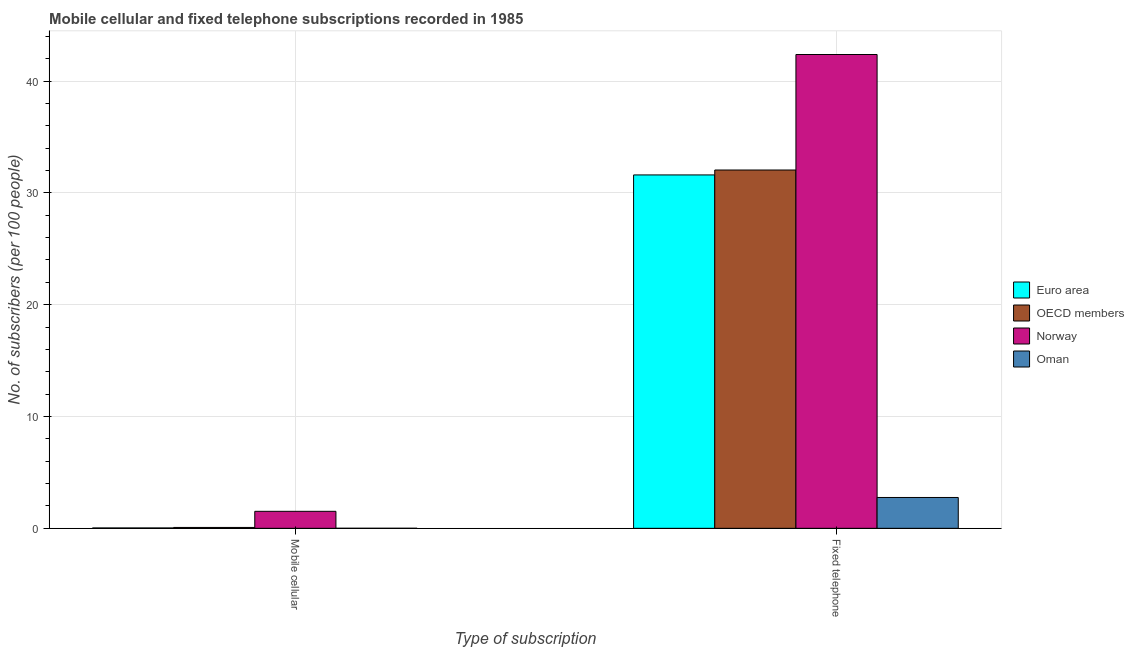How many different coloured bars are there?
Offer a very short reply. 4. How many groups of bars are there?
Your response must be concise. 2. How many bars are there on the 1st tick from the right?
Your answer should be compact. 4. What is the label of the 1st group of bars from the left?
Ensure brevity in your answer.  Mobile cellular. What is the number of fixed telephone subscribers in Oman?
Offer a very short reply. 2.76. Across all countries, what is the maximum number of mobile cellular subscribers?
Offer a terse response. 1.52. Across all countries, what is the minimum number of fixed telephone subscribers?
Offer a terse response. 2.76. In which country was the number of mobile cellular subscribers minimum?
Provide a succinct answer. Oman. What is the total number of mobile cellular subscribers in the graph?
Offer a terse response. 1.64. What is the difference between the number of mobile cellular subscribers in Euro area and that in OECD members?
Offer a terse response. -0.04. What is the difference between the number of mobile cellular subscribers in Norway and the number of fixed telephone subscribers in Oman?
Offer a very short reply. -1.24. What is the average number of mobile cellular subscribers per country?
Your answer should be very brief. 0.41. What is the difference between the number of fixed telephone subscribers and number of mobile cellular subscribers in OECD members?
Offer a terse response. 31.96. In how many countries, is the number of fixed telephone subscribers greater than 2 ?
Your answer should be very brief. 4. What is the ratio of the number of mobile cellular subscribers in Euro area to that in Norway?
Offer a terse response. 0.02. Is the number of fixed telephone subscribers in Euro area less than that in Oman?
Your response must be concise. No. In how many countries, is the number of mobile cellular subscribers greater than the average number of mobile cellular subscribers taken over all countries?
Offer a very short reply. 1. What does the 4th bar from the left in Mobile cellular represents?
Make the answer very short. Oman. What does the 3rd bar from the right in Fixed telephone represents?
Keep it short and to the point. OECD members. How many bars are there?
Make the answer very short. 8. Are all the bars in the graph horizontal?
Give a very brief answer. No. How many countries are there in the graph?
Your answer should be compact. 4. Are the values on the major ticks of Y-axis written in scientific E-notation?
Your response must be concise. No. Does the graph contain any zero values?
Provide a short and direct response. No. Does the graph contain grids?
Give a very brief answer. Yes. What is the title of the graph?
Your answer should be compact. Mobile cellular and fixed telephone subscriptions recorded in 1985. What is the label or title of the X-axis?
Keep it short and to the point. Type of subscription. What is the label or title of the Y-axis?
Your response must be concise. No. of subscribers (per 100 people). What is the No. of subscribers (per 100 people) of Euro area in Mobile cellular?
Offer a very short reply. 0.03. What is the No. of subscribers (per 100 people) of OECD members in Mobile cellular?
Your answer should be compact. 0.08. What is the No. of subscribers (per 100 people) in Norway in Mobile cellular?
Give a very brief answer. 1.52. What is the No. of subscribers (per 100 people) in Oman in Mobile cellular?
Make the answer very short. 0. What is the No. of subscribers (per 100 people) in Euro area in Fixed telephone?
Provide a succinct answer. 31.6. What is the No. of subscribers (per 100 people) of OECD members in Fixed telephone?
Make the answer very short. 32.04. What is the No. of subscribers (per 100 people) of Norway in Fixed telephone?
Offer a very short reply. 42.37. What is the No. of subscribers (per 100 people) in Oman in Fixed telephone?
Offer a very short reply. 2.76. Across all Type of subscription, what is the maximum No. of subscribers (per 100 people) in Euro area?
Your response must be concise. 31.6. Across all Type of subscription, what is the maximum No. of subscribers (per 100 people) of OECD members?
Provide a short and direct response. 32.04. Across all Type of subscription, what is the maximum No. of subscribers (per 100 people) of Norway?
Your response must be concise. 42.37. Across all Type of subscription, what is the maximum No. of subscribers (per 100 people) of Oman?
Keep it short and to the point. 2.76. Across all Type of subscription, what is the minimum No. of subscribers (per 100 people) in Euro area?
Keep it short and to the point. 0.03. Across all Type of subscription, what is the minimum No. of subscribers (per 100 people) of OECD members?
Give a very brief answer. 0.08. Across all Type of subscription, what is the minimum No. of subscribers (per 100 people) in Norway?
Your answer should be compact. 1.52. Across all Type of subscription, what is the minimum No. of subscribers (per 100 people) of Oman?
Your answer should be compact. 0. What is the total No. of subscribers (per 100 people) of Euro area in the graph?
Your answer should be very brief. 31.64. What is the total No. of subscribers (per 100 people) in OECD members in the graph?
Keep it short and to the point. 32.12. What is the total No. of subscribers (per 100 people) in Norway in the graph?
Your answer should be compact. 43.89. What is the total No. of subscribers (per 100 people) in Oman in the graph?
Your response must be concise. 2.76. What is the difference between the No. of subscribers (per 100 people) in Euro area in Mobile cellular and that in Fixed telephone?
Keep it short and to the point. -31.57. What is the difference between the No. of subscribers (per 100 people) of OECD members in Mobile cellular and that in Fixed telephone?
Offer a terse response. -31.96. What is the difference between the No. of subscribers (per 100 people) of Norway in Mobile cellular and that in Fixed telephone?
Make the answer very short. -40.85. What is the difference between the No. of subscribers (per 100 people) of Oman in Mobile cellular and that in Fixed telephone?
Your response must be concise. -2.75. What is the difference between the No. of subscribers (per 100 people) in Euro area in Mobile cellular and the No. of subscribers (per 100 people) in OECD members in Fixed telephone?
Your response must be concise. -32.01. What is the difference between the No. of subscribers (per 100 people) in Euro area in Mobile cellular and the No. of subscribers (per 100 people) in Norway in Fixed telephone?
Offer a terse response. -42.34. What is the difference between the No. of subscribers (per 100 people) of Euro area in Mobile cellular and the No. of subscribers (per 100 people) of Oman in Fixed telephone?
Give a very brief answer. -2.72. What is the difference between the No. of subscribers (per 100 people) in OECD members in Mobile cellular and the No. of subscribers (per 100 people) in Norway in Fixed telephone?
Provide a succinct answer. -42.29. What is the difference between the No. of subscribers (per 100 people) of OECD members in Mobile cellular and the No. of subscribers (per 100 people) of Oman in Fixed telephone?
Offer a terse response. -2.68. What is the difference between the No. of subscribers (per 100 people) in Norway in Mobile cellular and the No. of subscribers (per 100 people) in Oman in Fixed telephone?
Your answer should be compact. -1.24. What is the average No. of subscribers (per 100 people) in Euro area per Type of subscription?
Ensure brevity in your answer.  15.82. What is the average No. of subscribers (per 100 people) of OECD members per Type of subscription?
Provide a succinct answer. 16.06. What is the average No. of subscribers (per 100 people) in Norway per Type of subscription?
Provide a short and direct response. 21.95. What is the average No. of subscribers (per 100 people) in Oman per Type of subscription?
Make the answer very short. 1.38. What is the difference between the No. of subscribers (per 100 people) of Euro area and No. of subscribers (per 100 people) of OECD members in Mobile cellular?
Provide a succinct answer. -0.04. What is the difference between the No. of subscribers (per 100 people) of Euro area and No. of subscribers (per 100 people) of Norway in Mobile cellular?
Your answer should be very brief. -1.49. What is the difference between the No. of subscribers (per 100 people) of Euro area and No. of subscribers (per 100 people) of Oman in Mobile cellular?
Offer a very short reply. 0.03. What is the difference between the No. of subscribers (per 100 people) in OECD members and No. of subscribers (per 100 people) in Norway in Mobile cellular?
Ensure brevity in your answer.  -1.44. What is the difference between the No. of subscribers (per 100 people) in OECD members and No. of subscribers (per 100 people) in Oman in Mobile cellular?
Offer a very short reply. 0.07. What is the difference between the No. of subscribers (per 100 people) in Norway and No. of subscribers (per 100 people) in Oman in Mobile cellular?
Your answer should be very brief. 1.52. What is the difference between the No. of subscribers (per 100 people) of Euro area and No. of subscribers (per 100 people) of OECD members in Fixed telephone?
Give a very brief answer. -0.44. What is the difference between the No. of subscribers (per 100 people) in Euro area and No. of subscribers (per 100 people) in Norway in Fixed telephone?
Provide a short and direct response. -10.77. What is the difference between the No. of subscribers (per 100 people) of Euro area and No. of subscribers (per 100 people) of Oman in Fixed telephone?
Offer a very short reply. 28.84. What is the difference between the No. of subscribers (per 100 people) in OECD members and No. of subscribers (per 100 people) in Norway in Fixed telephone?
Your answer should be very brief. -10.33. What is the difference between the No. of subscribers (per 100 people) of OECD members and No. of subscribers (per 100 people) of Oman in Fixed telephone?
Your answer should be compact. 29.28. What is the difference between the No. of subscribers (per 100 people) of Norway and No. of subscribers (per 100 people) of Oman in Fixed telephone?
Keep it short and to the point. 39.61. What is the ratio of the No. of subscribers (per 100 people) in Euro area in Mobile cellular to that in Fixed telephone?
Offer a very short reply. 0. What is the ratio of the No. of subscribers (per 100 people) of OECD members in Mobile cellular to that in Fixed telephone?
Give a very brief answer. 0. What is the ratio of the No. of subscribers (per 100 people) of Norway in Mobile cellular to that in Fixed telephone?
Ensure brevity in your answer.  0.04. What is the ratio of the No. of subscribers (per 100 people) in Oman in Mobile cellular to that in Fixed telephone?
Your response must be concise. 0. What is the difference between the highest and the second highest No. of subscribers (per 100 people) in Euro area?
Your answer should be compact. 31.57. What is the difference between the highest and the second highest No. of subscribers (per 100 people) in OECD members?
Offer a very short reply. 31.96. What is the difference between the highest and the second highest No. of subscribers (per 100 people) in Norway?
Ensure brevity in your answer.  40.85. What is the difference between the highest and the second highest No. of subscribers (per 100 people) of Oman?
Give a very brief answer. 2.75. What is the difference between the highest and the lowest No. of subscribers (per 100 people) in Euro area?
Offer a very short reply. 31.57. What is the difference between the highest and the lowest No. of subscribers (per 100 people) in OECD members?
Offer a very short reply. 31.96. What is the difference between the highest and the lowest No. of subscribers (per 100 people) in Norway?
Offer a terse response. 40.85. What is the difference between the highest and the lowest No. of subscribers (per 100 people) in Oman?
Your answer should be very brief. 2.75. 